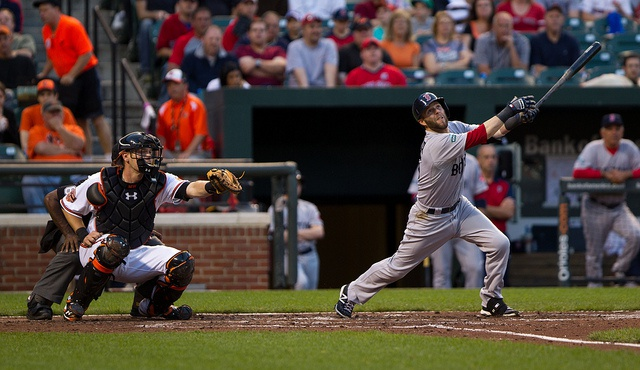Describe the objects in this image and their specific colors. I can see people in black, gray, maroon, and darkgray tones, people in black, lavender, gray, and maroon tones, people in black, gray, darkgray, and lightgray tones, people in black, red, maroon, and brown tones, and people in black, maroon, brown, red, and gray tones in this image. 